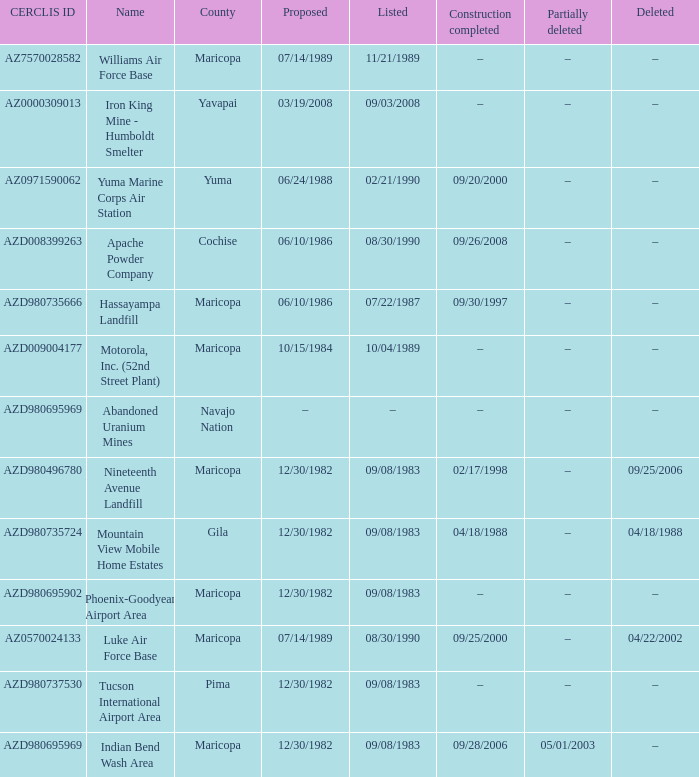When was the site listed when the county is cochise? 08/30/1990. Help me parse the entirety of this table. {'header': ['CERCLIS ID', 'Name', 'County', 'Proposed', 'Listed', 'Construction completed', 'Partially deleted', 'Deleted'], 'rows': [['AZ7570028582', 'Williams Air Force Base', 'Maricopa', '07/14/1989', '11/21/1989', '–', '–', '–'], ['AZ0000309013', 'Iron King Mine - Humboldt Smelter', 'Yavapai', '03/19/2008', '09/03/2008', '–', '–', '–'], ['AZ0971590062', 'Yuma Marine Corps Air Station', 'Yuma', '06/24/1988', '02/21/1990', '09/20/2000', '–', '–'], ['AZD008399263', 'Apache Powder Company', 'Cochise', '06/10/1986', '08/30/1990', '09/26/2008', '–', '–'], ['AZD980735666', 'Hassayampa Landfill', 'Maricopa', '06/10/1986', '07/22/1987', '09/30/1997', '–', '–'], ['AZD009004177', 'Motorola, Inc. (52nd Street Plant)', 'Maricopa', '10/15/1984', '10/04/1989', '–', '–', '–'], ['AZD980695969', 'Abandoned Uranium Mines', 'Navajo Nation', '–', '–', '–', '–', '–'], ['AZD980496780', 'Nineteenth Avenue Landfill', 'Maricopa', '12/30/1982', '09/08/1983', '02/17/1998', '–', '09/25/2006'], ['AZD980735724', 'Mountain View Mobile Home Estates', 'Gila', '12/30/1982', '09/08/1983', '04/18/1988', '–', '04/18/1988'], ['AZD980695902', 'Phoenix-Goodyear Airport Area', 'Maricopa', '12/30/1982', '09/08/1983', '–', '–', '–'], ['AZ0570024133', 'Luke Air Force Base', 'Maricopa', '07/14/1989', '08/30/1990', '09/25/2000', '–', '04/22/2002'], ['AZD980737530', 'Tucson International Airport Area', 'Pima', '12/30/1982', '09/08/1983', '–', '–', '–'], ['AZD980695969', 'Indian Bend Wash Area', 'Maricopa', '12/30/1982', '09/08/1983', '09/28/2006', '05/01/2003', '–']]} 